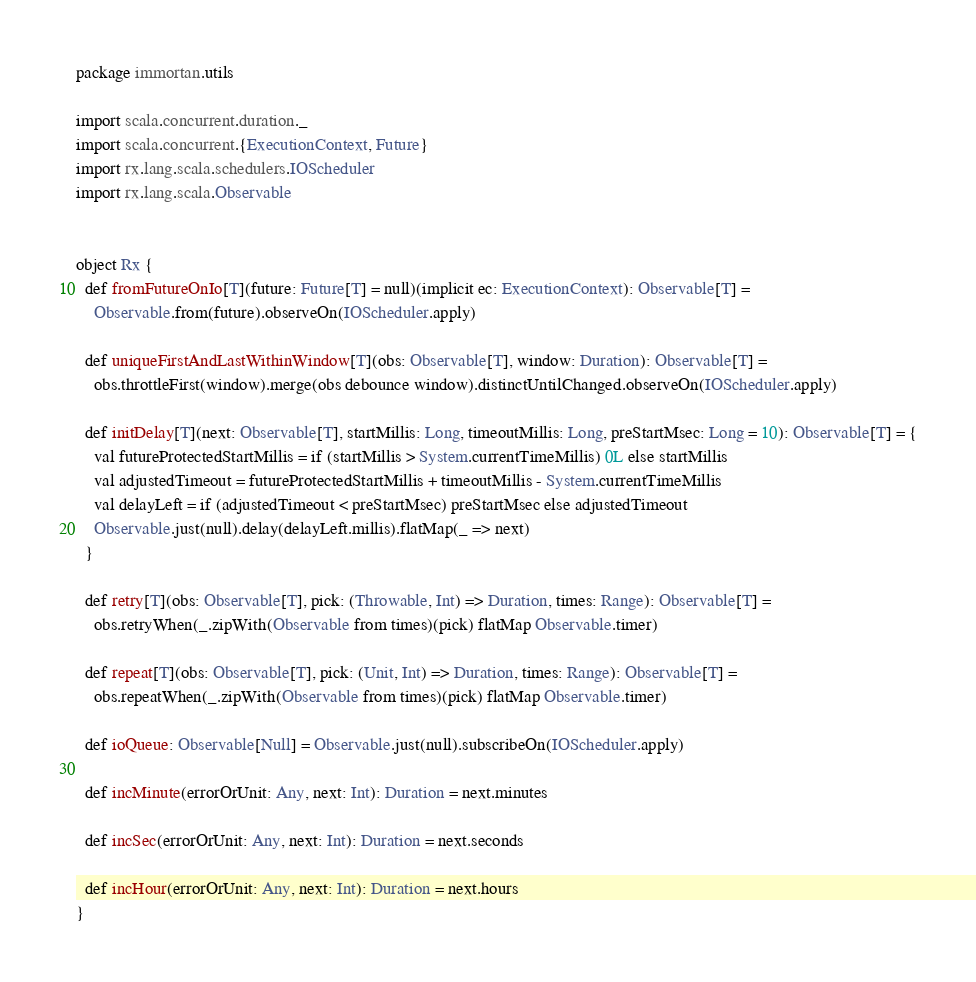<code> <loc_0><loc_0><loc_500><loc_500><_Scala_>package immortan.utils

import scala.concurrent.duration._
import scala.concurrent.{ExecutionContext, Future}
import rx.lang.scala.schedulers.IOScheduler
import rx.lang.scala.Observable


object Rx {
  def fromFutureOnIo[T](future: Future[T] = null)(implicit ec: ExecutionContext): Observable[T] =
    Observable.from(future).observeOn(IOScheduler.apply)

  def uniqueFirstAndLastWithinWindow[T](obs: Observable[T], window: Duration): Observable[T] =
    obs.throttleFirst(window).merge(obs debounce window).distinctUntilChanged.observeOn(IOScheduler.apply)

  def initDelay[T](next: Observable[T], startMillis: Long, timeoutMillis: Long, preStartMsec: Long = 10): Observable[T] = {
    val futureProtectedStartMillis = if (startMillis > System.currentTimeMillis) 0L else startMillis
    val adjustedTimeout = futureProtectedStartMillis + timeoutMillis - System.currentTimeMillis
    val delayLeft = if (adjustedTimeout < preStartMsec) preStartMsec else adjustedTimeout
    Observable.just(null).delay(delayLeft.millis).flatMap(_ => next)
  }

  def retry[T](obs: Observable[T], pick: (Throwable, Int) => Duration, times: Range): Observable[T] =
    obs.retryWhen(_.zipWith(Observable from times)(pick) flatMap Observable.timer)

  def repeat[T](obs: Observable[T], pick: (Unit, Int) => Duration, times: Range): Observable[T] =
    obs.repeatWhen(_.zipWith(Observable from times)(pick) flatMap Observable.timer)

  def ioQueue: Observable[Null] = Observable.just(null).subscribeOn(IOScheduler.apply)

  def incMinute(errorOrUnit: Any, next: Int): Duration = next.minutes

  def incSec(errorOrUnit: Any, next: Int): Duration = next.seconds

  def incHour(errorOrUnit: Any, next: Int): Duration = next.hours
}
</code> 